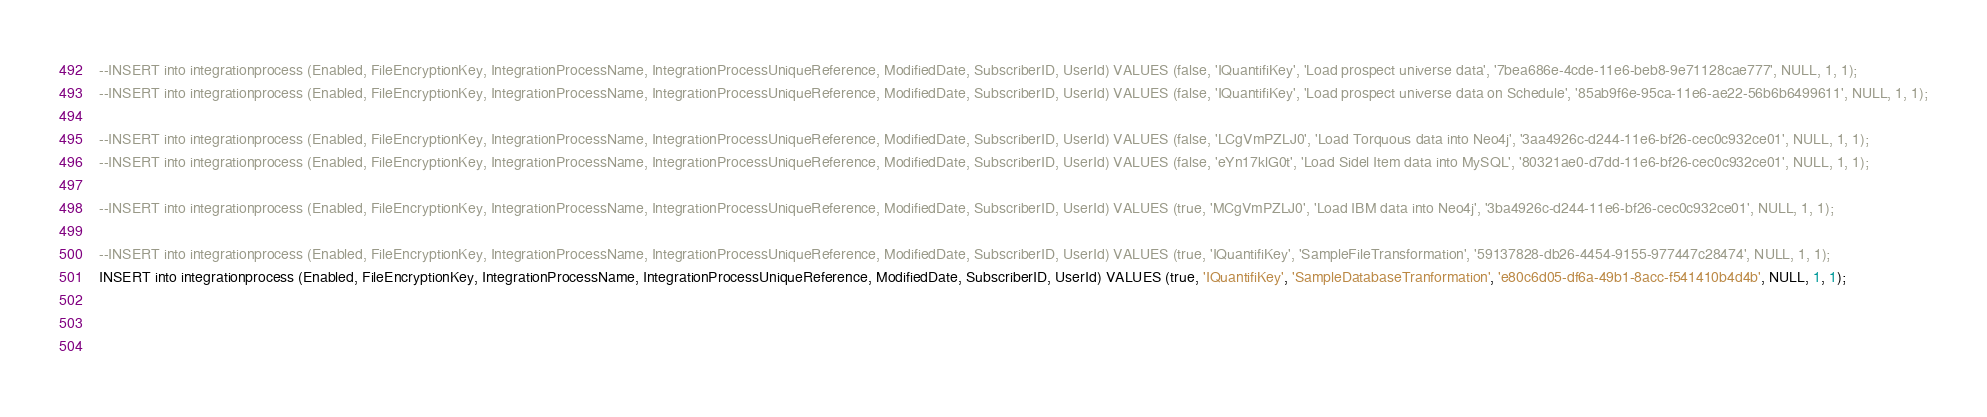<code> <loc_0><loc_0><loc_500><loc_500><_SQL_>--INSERT into integrationprocess (Enabled, FileEncryptionKey, IntegrationProcessName, IntegrationProcessUniqueReference, ModifiedDate, SubscriberID, UserId) VALUES (false, 'IQuantifiKey', 'Load prospect universe data', '7bea686e-4cde-11e6-beb8-9e71128cae777', NULL, 1, 1);
--INSERT into integrationprocess (Enabled, FileEncryptionKey, IntegrationProcessName, IntegrationProcessUniqueReference, ModifiedDate, SubscriberID, UserId) VALUES (false, 'IQuantifiKey', 'Load prospect universe data on Schedule', '85ab9f6e-95ca-11e6-ae22-56b6b6499611', NULL, 1, 1);

--INSERT into integrationprocess (Enabled, FileEncryptionKey, IntegrationProcessName, IntegrationProcessUniqueReference, ModifiedDate, SubscriberID, UserId) VALUES (false, 'LCgVmPZLJ0', 'Load Torquous data into Neo4j', '3aa4926c-d244-11e6-bf26-cec0c932ce01', NULL, 1, 1);
--INSERT into integrationprocess (Enabled, FileEncryptionKey, IntegrationProcessName, IntegrationProcessUniqueReference, ModifiedDate, SubscriberID, UserId) VALUES (false, 'eYn17klG0t', 'Load Sidel Item data into MySQL', '80321ae0-d7dd-11e6-bf26-cec0c932ce01', NULL, 1, 1);

--INSERT into integrationprocess (Enabled, FileEncryptionKey, IntegrationProcessName, IntegrationProcessUniqueReference, ModifiedDate, SubscriberID, UserId) VALUES (true, 'MCgVmPZLJ0', 'Load IBM data into Neo4j', '3ba4926c-d244-11e6-bf26-cec0c932ce01', NULL, 1, 1);

--INSERT into integrationprocess (Enabled, FileEncryptionKey, IntegrationProcessName, IntegrationProcessUniqueReference, ModifiedDate, SubscriberID, UserId) VALUES (true, 'IQuantifiKey', 'SampleFileTransformation', '59137828-db26-4454-9155-977447c28474', NULL, 1, 1);
INSERT into integrationprocess (Enabled, FileEncryptionKey, IntegrationProcessName, IntegrationProcessUniqueReference, ModifiedDate, SubscriberID, UserId) VALUES (true, 'IQuantifiKey', 'SampleDatabaseTranformation', 'e80c6d05-df6a-49b1-8acc-f541410b4d4b', NULL, 1, 1);


 </code> 